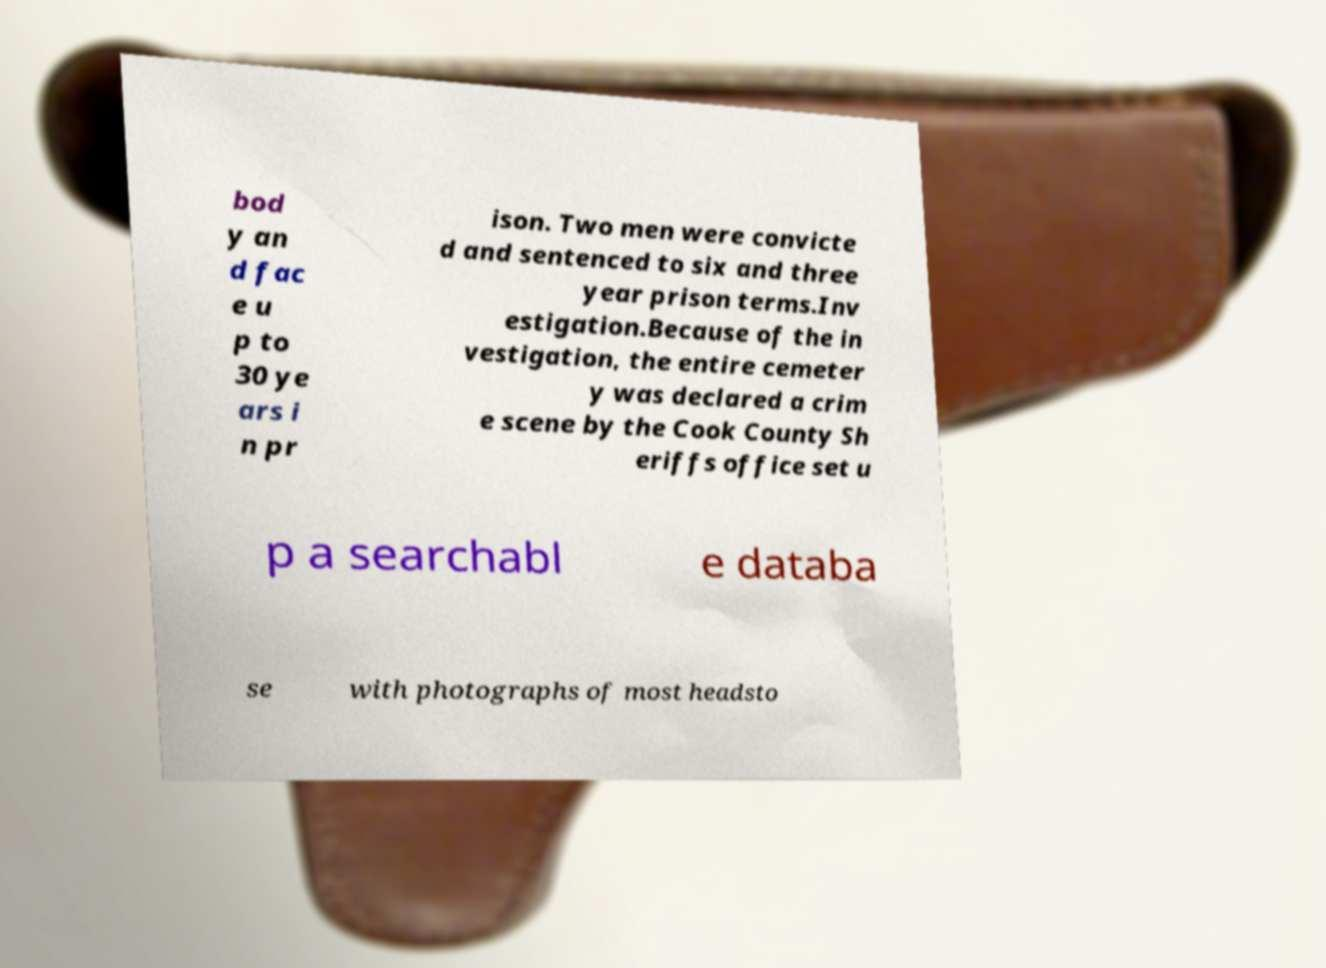Can you accurately transcribe the text from the provided image for me? bod y an d fac e u p to 30 ye ars i n pr ison. Two men were convicte d and sentenced to six and three year prison terms.Inv estigation.Because of the in vestigation, the entire cemeter y was declared a crim e scene by the Cook County Sh eriffs office set u p a searchabl e databa se with photographs of most headsto 